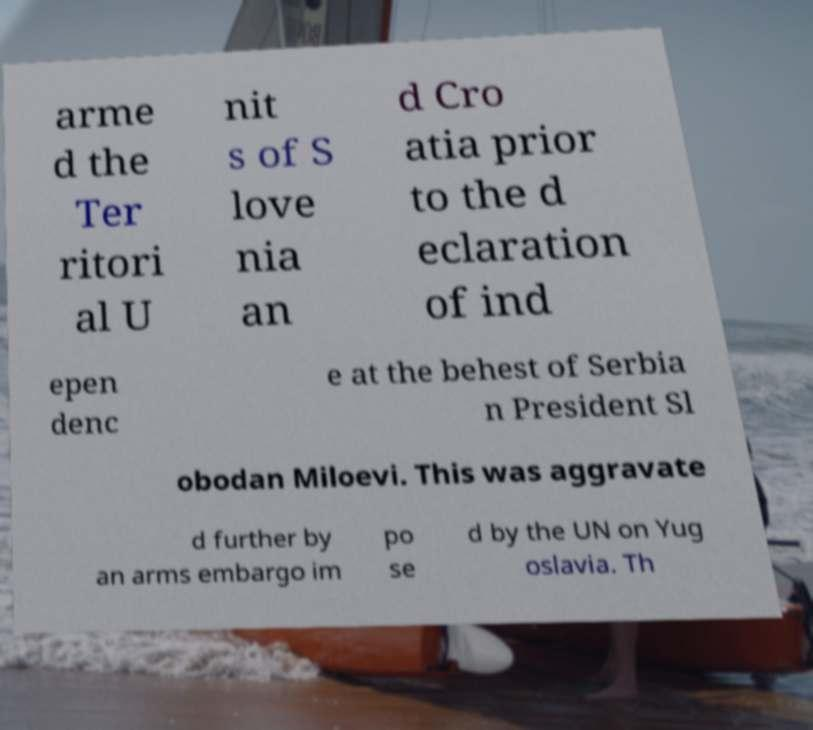Could you extract and type out the text from this image? arme d the Ter ritori al U nit s of S love nia an d Cro atia prior to the d eclaration of ind epen denc e at the behest of Serbia n President Sl obodan Miloevi. This was aggravate d further by an arms embargo im po se d by the UN on Yug oslavia. Th 